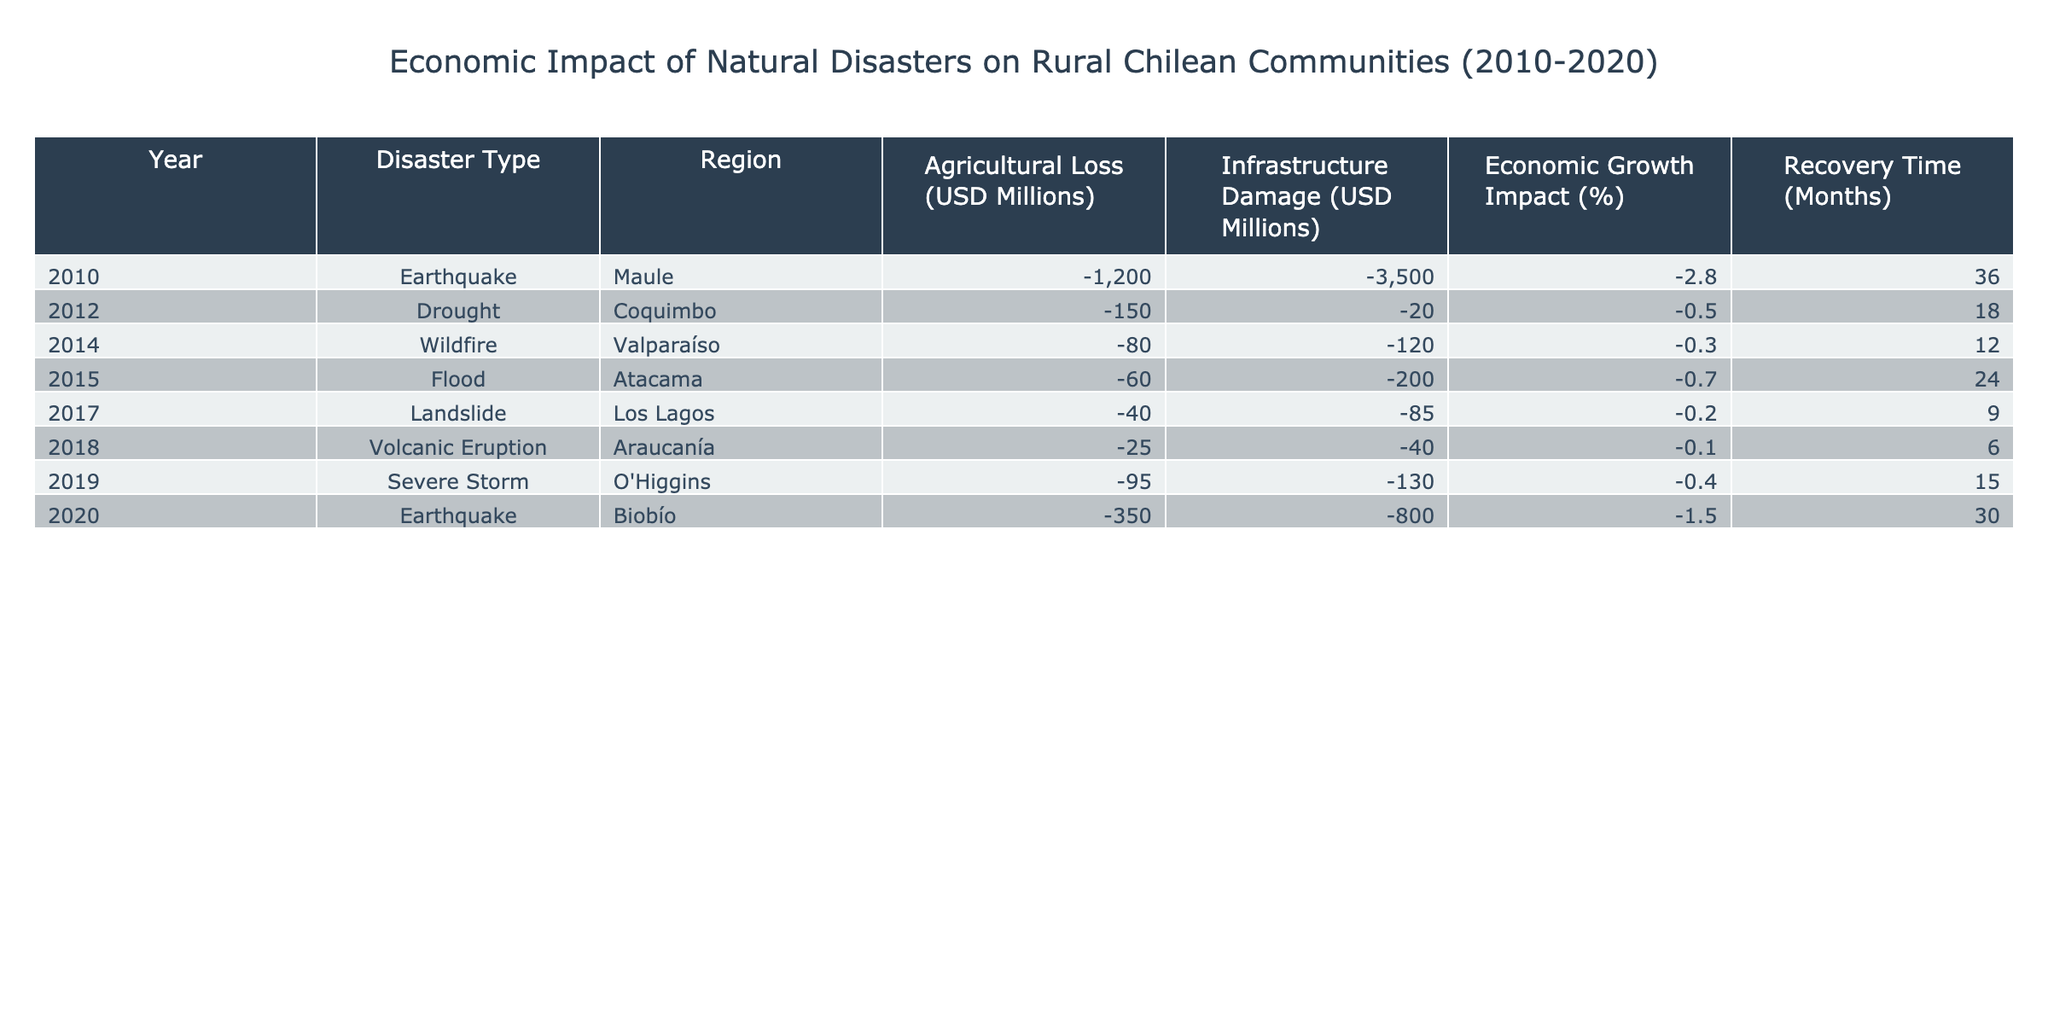What is the total agricultural loss due to all disasters from 2010 to 2020? To find the total agricultural loss, we sum the losses: -1200 + (-150) + (-80) + (-60) + (-40) + (-25) + (-95) + (-350) = -2000 million USD.
Answer: -2000 million USD Which disaster caused the highest infrastructure damage? From the table, the earthquake in 2010 caused the highest infrastructure damage of -3500 million USD.
Answer: -3500 million USD What was the average economic growth impact for all disasters recorded? We calculate the average by summing all economic growth impacts: (-2.8 + (-0.5) + (-0.3) + (-0.7) + (-0.2) + (-0.1) + (-0.4) + (-1.5)) and dividing by 8, which gives us -6.6/8 = -0.825%.
Answer: -0.825% Is the recovery time after the 2018 volcanic eruption shorter than that of the 2012 drought? The recovery time after the 2018 eruption is 6 months and after the 2012 drought is 18 months. Since 6 is less than 18, the statement is true.
Answer: Yes Which year saw the least economic growth impact and what was the percentage? The least economic growth impact occurred in 2018 with -0.1%.
Answer: -0.1% What is the difference between agricultural losses in 2020 and 2010? The agricultural loss in 2020 was -350 million USD and in 2010 it was -1200 million USD. The difference is -350 - (-1200) = 850 million USD.
Answer: 850 million USD Was there any disaster with more than 100 million USD in agricultural loss? Looking through the agricultural loss figures, only the earthquake in 2010 exceeded 100 million USD. Therefore, the statement is true.
Answer: Yes What regions experienced economic growth impacts less than -0.5%? The regions with economic growth impacts less than -0.5% are Maule, Coquimbo, and Biobío, as their impacts were -2.8%, -0.5%, and -1.5%, respectively.
Answer: Maule, Coquimbo, and Biobío How many months did it take to recover from the disaster that caused the greatest agricultural loss? The disaster with the greatest agricultural loss was the earthquake in Maule in 2010, which had a recovery time of 36 months.
Answer: 36 months What is the total infrastructure damage across all recorded disasters? Summing the infrastructure damages gives us: -3500 + (-20) + (-120) + (-200) + (-85) + (-40) + (-130) + (-800) = -4905 million USD.
Answer: -4905 million USD 